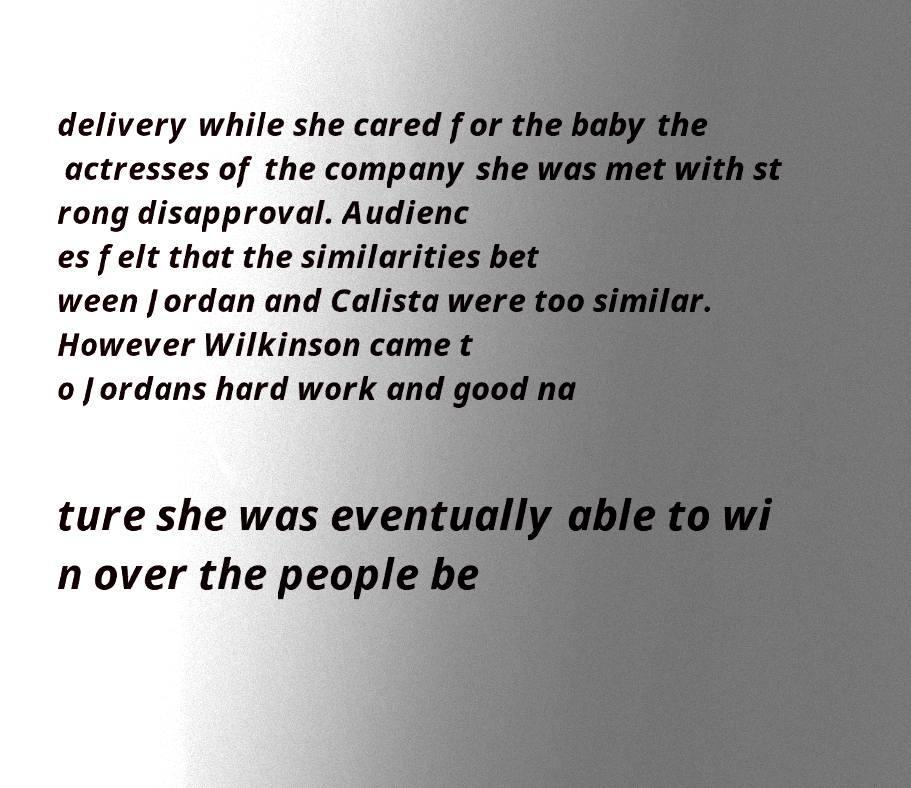Can you read and provide the text displayed in the image?This photo seems to have some interesting text. Can you extract and type it out for me? delivery while she cared for the baby the actresses of the company she was met with st rong disapproval. Audienc es felt that the similarities bet ween Jordan and Calista were too similar. However Wilkinson came t o Jordans hard work and good na ture she was eventually able to wi n over the people be 